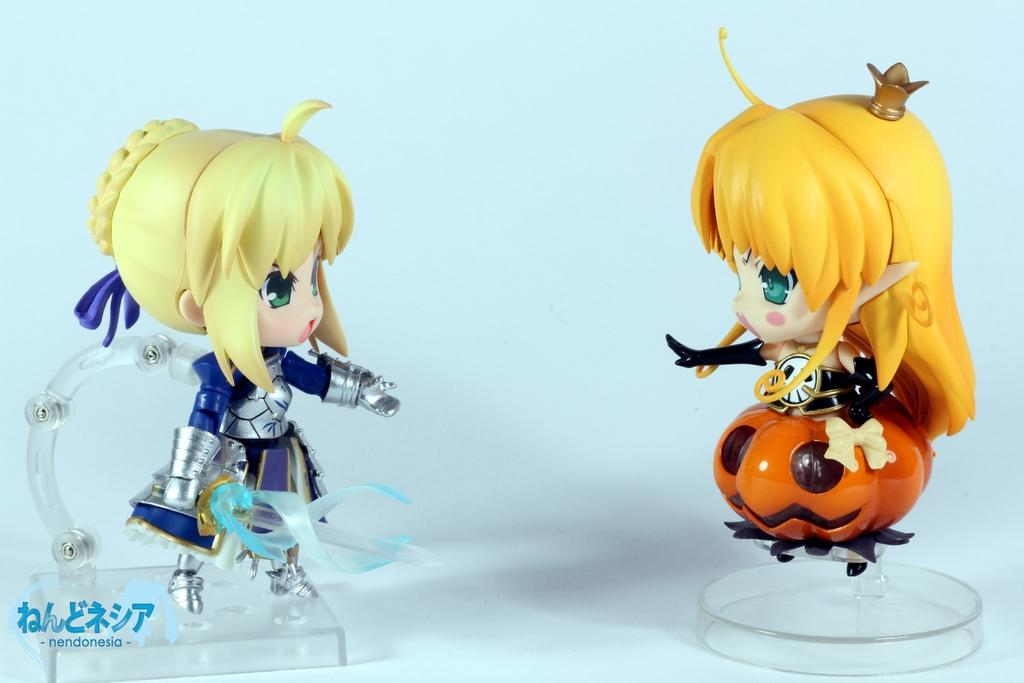What objects are present in the image? There are two toys in the image. What is the color of the surface on which the toys are placed? The toys are on a white surface. Is there any additional information or marking in the image? Yes, there is a watermark at the bottom left corner of the image. Where is the mom in the image? There is no mom present in the image; it only features two toys on a white surface and a watermark. What type of army is depicted in the image? There is no army present in the image; it only features two toys on a white surface and a watermark. 